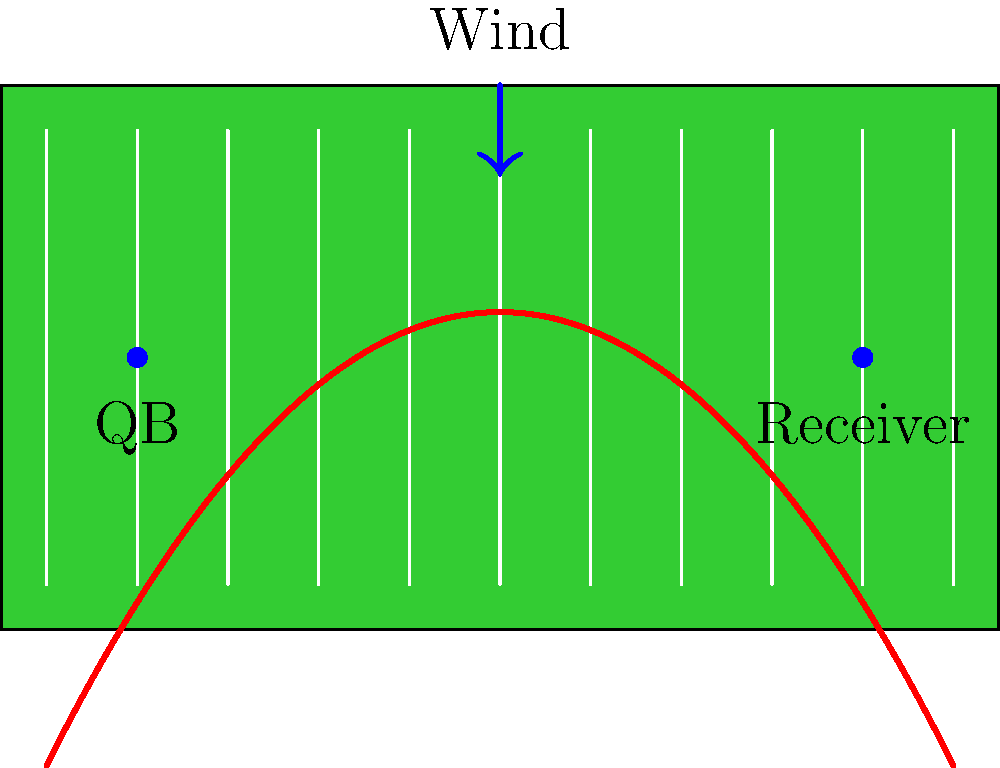As a former football player, you're analyzing a crucial pass play. The diagram shows a parabolic trajectory of a pass on a football field, with the quarterback (QB) at the 10-yard line and the receiver at the 90-yard line. A strong wind is blowing straight down the field. Based on your experience, which of the following statements is most likely true about this pass?

A) The pass will be completed successfully
B) The pass will fall short of the receiver
C) The pass will overshoot the receiver
D) The wind will have no effect on the pass Let's analyze this situation step-by-step:

1) The parabolic curve represents the trajectory of the football pass.

2) The vertex of the parabola appears to be slightly past the midpoint of the field, around the 55-yard line.

3) The QB is at the 10-yard line, and the receiver is at the 90-yard line, indicating an 80-yard pass attempt.

4) The trajectory shows the ball reaching the receiver's position at the apex of its flight.

5) However, we need to consider the wind factor. The arrow indicates a strong wind blowing straight down the field, in the same direction as the pass.

6) In football, wind can significantly affect long passes. A tailwind (wind blowing in the same direction as the pass) tends to make the ball travel farther than it would in still conditions.

7) Given that the parabolic trajectory already reaches the receiver without accounting for wind, the additional push from the tailwind is likely to cause the ball to overshoot the receiver.

8) As an experienced player and commentator, you would recognize that quarterbacks typically adjust for wind by "underthrowing" in tailwind conditions. The fact that this pass appears to be on target without accounting for wind suggests it will likely overshoot.

Therefore, based on the trajectory shown and the wind condition, the most likely outcome is that the pass will overshoot the receiver.
Answer: C) The pass will overshoot the receiver 